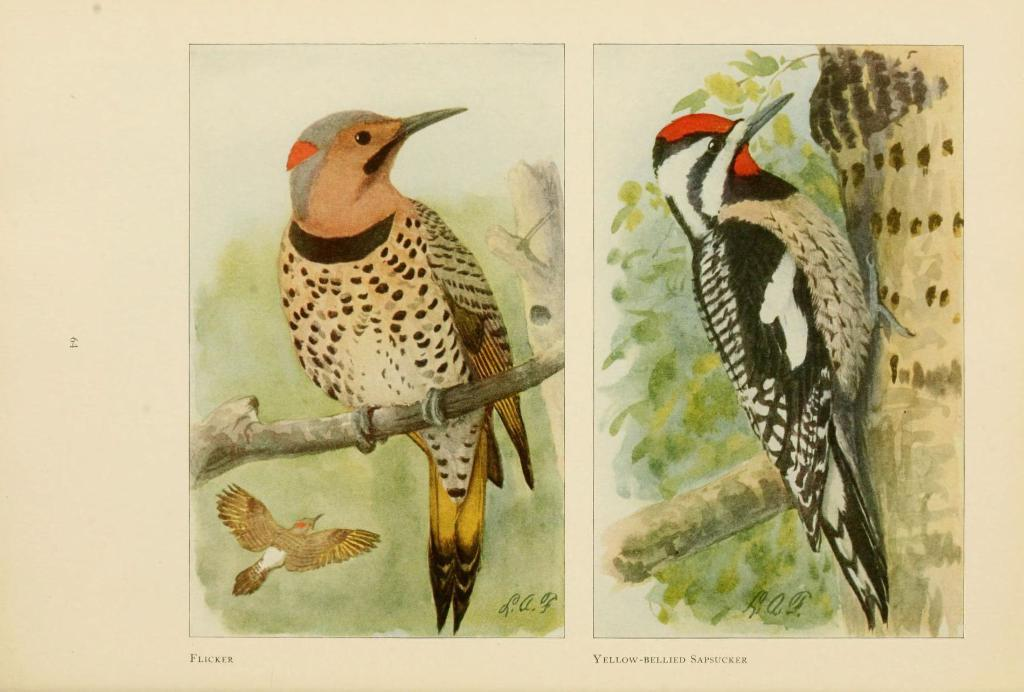What type of artwork is shown in the image? The image is a painting. What animal is featured in the painting? The painting contains a bird. Where is the bird located in the painting? The bird is depicted on a tree. What type of waste is visible in the image? There is no waste present in the image; it is a painting featuring a bird on a tree. How many tomatoes are hanging from the tree in the image? There are no tomatoes present in the image; it features a bird on a tree. 